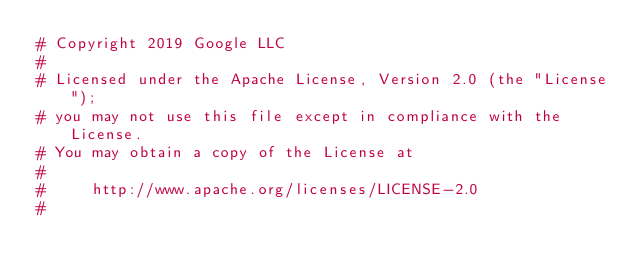<code> <loc_0><loc_0><loc_500><loc_500><_Elixir_># Copyright 2019 Google LLC
#
# Licensed under the Apache License, Version 2.0 (the "License");
# you may not use this file except in compliance with the License.
# You may obtain a copy of the License at
#
#     http://www.apache.org/licenses/LICENSE-2.0
#</code> 